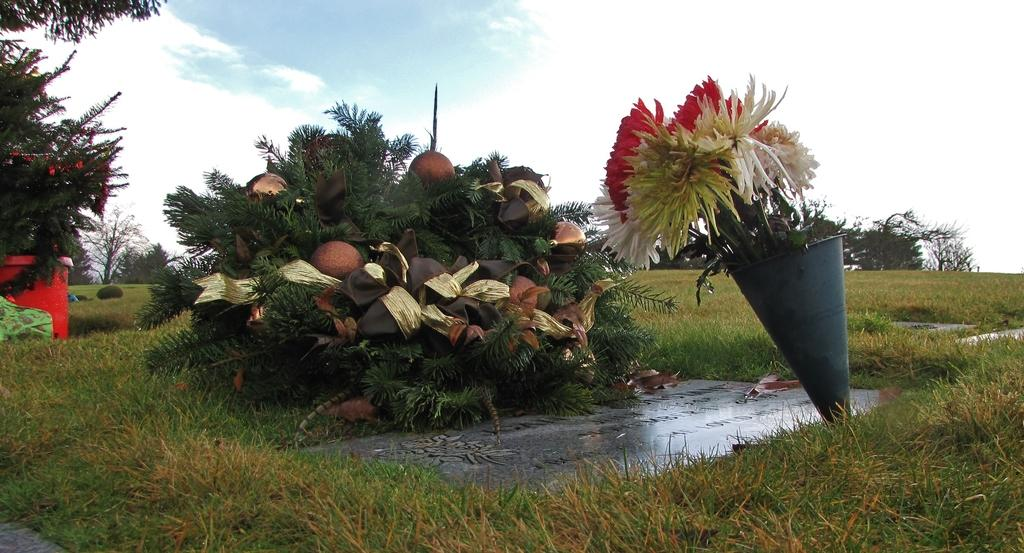What type of vegetation can be seen in the image? There are flowers, grass, plants, and trees visible in the image. What is on the ground in the image? There are other objects on the ground in the image. What can be seen in the background of the image? The sky is visible in the background of the image. What type of wound can be seen on the table in the image? There is no table or wound present in the image. 